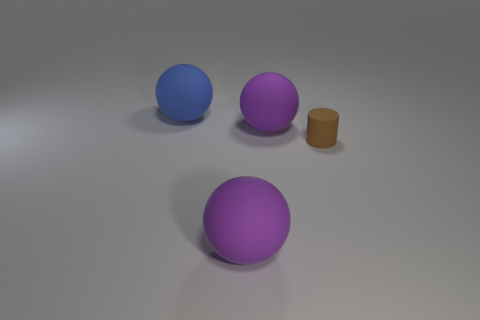What number of other things are there of the same size as the brown rubber cylinder?
Offer a terse response. 0. How many cylinders are left of the rubber ball on the right side of the purple ball in front of the tiny brown cylinder?
Your answer should be compact. 0. Are there any blue matte things in front of the brown thing?
Keep it short and to the point. No. Are there any other things that are the same color as the small matte cylinder?
Ensure brevity in your answer.  No. How many balls are either metal objects or tiny brown rubber objects?
Offer a terse response. 0. What number of big purple matte objects are both in front of the brown matte cylinder and behind the brown matte thing?
Your answer should be very brief. 0. Are there an equal number of matte objects to the right of the big blue rubber thing and brown cylinders to the right of the cylinder?
Your response must be concise. No. There is a thing in front of the tiny brown cylinder; is it the same shape as the large blue matte thing?
Provide a succinct answer. Yes. The big object that is to the left of the large ball that is in front of the big purple thing behind the rubber cylinder is what shape?
Give a very brief answer. Sphere. What is the thing that is both behind the brown rubber object and in front of the blue matte ball made of?
Ensure brevity in your answer.  Rubber. 